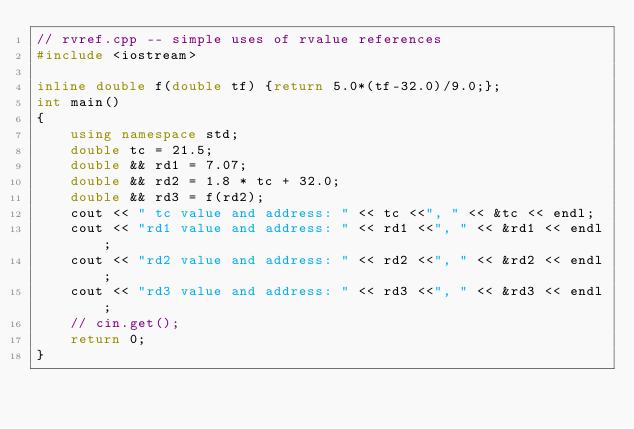<code> <loc_0><loc_0><loc_500><loc_500><_C++_>// rvref.cpp -- simple uses of rvalue references
#include <iostream>

inline double f(double tf) {return 5.0*(tf-32.0)/9.0;};
int main()
{
    using namespace std;
    double tc = 21.5;
    double && rd1 = 7.07;
    double && rd2 = 1.8 * tc + 32.0;
    double && rd3 = f(rd2);
    cout << " tc value and address: " << tc <<", " << &tc << endl;
    cout << "rd1 value and address: " << rd1 <<", " << &rd1 << endl;
    cout << "rd2 value and address: " << rd2 <<", " << &rd2 << endl;
    cout << "rd3 value and address: " << rd3 <<", " << &rd3 << endl;
    // cin.get();
    return 0;
}
</code> 